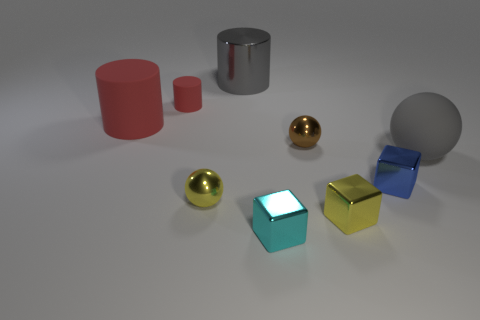What colors can you see on the objects presented in the image? The image displays objects in several colors including red, gold, silver, green, blue, and gray. Some objects reflect the environment which adds a range of subtly varied tones to their surfaces. 